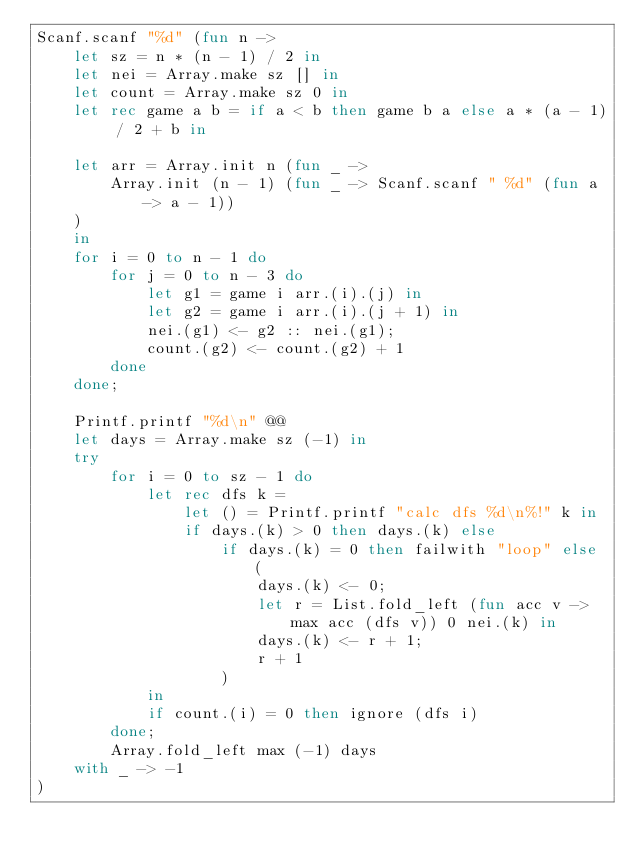Convert code to text. <code><loc_0><loc_0><loc_500><loc_500><_OCaml_>Scanf.scanf "%d" (fun n ->
    let sz = n * (n - 1) / 2 in
    let nei = Array.make sz [] in
    let count = Array.make sz 0 in
    let rec game a b = if a < b then game b a else a * (a - 1) / 2 + b in

    let arr = Array.init n (fun _ ->
        Array.init (n - 1) (fun _ -> Scanf.scanf " %d" (fun a -> a - 1))
    )
    in
    for i = 0 to n - 1 do
        for j = 0 to n - 3 do
            let g1 = game i arr.(i).(j) in
            let g2 = game i arr.(i).(j + 1) in
            nei.(g1) <- g2 :: nei.(g1);
            count.(g2) <- count.(g2) + 1
        done
    done;

    Printf.printf "%d\n" @@
    let days = Array.make sz (-1) in
    try
        for i = 0 to sz - 1 do
            let rec dfs k =
                let () = Printf.printf "calc dfs %d\n%!" k in
                if days.(k) > 0 then days.(k) else
                    if days.(k) = 0 then failwith "loop" else (
                        days.(k) <- 0;
                        let r = List.fold_left (fun acc v -> max acc (dfs v)) 0 nei.(k) in
                        days.(k) <- r + 1;
                        r + 1
                    )
            in
            if count.(i) = 0 then ignore (dfs i)
        done;
        Array.fold_left max (-1) days
    with _ -> -1
)</code> 